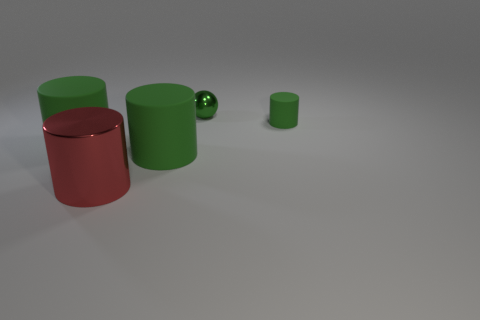How many objects are there in total in this image? There are four objects in the image: two green cylinders, one red cylinder, and a small green sphere. 